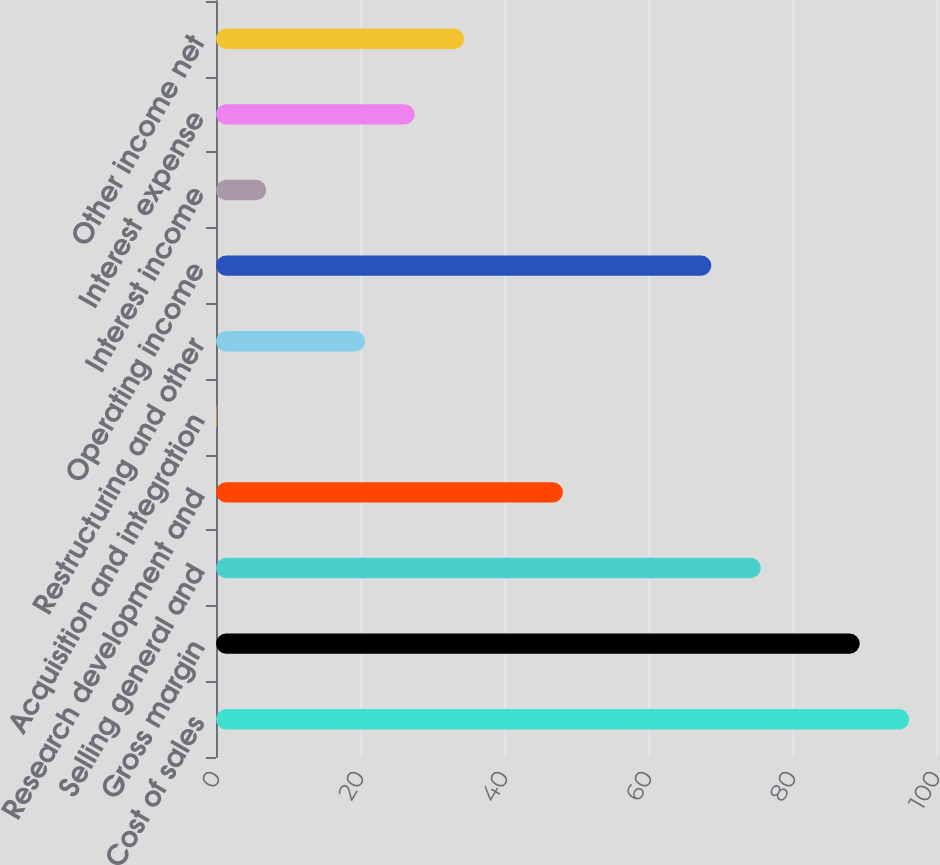<chart> <loc_0><loc_0><loc_500><loc_500><bar_chart><fcel>Cost of sales<fcel>Gross margin<fcel>Selling general and<fcel>Research development and<fcel>Acquisition and integration<fcel>Restructuring and other<fcel>Operating income<fcel>Interest income<fcel>Interest expense<fcel>Other income net<nl><fcel>96.28<fcel>89.41<fcel>75.67<fcel>48.19<fcel>0.1<fcel>20.71<fcel>68.8<fcel>6.97<fcel>27.58<fcel>34.45<nl></chart> 